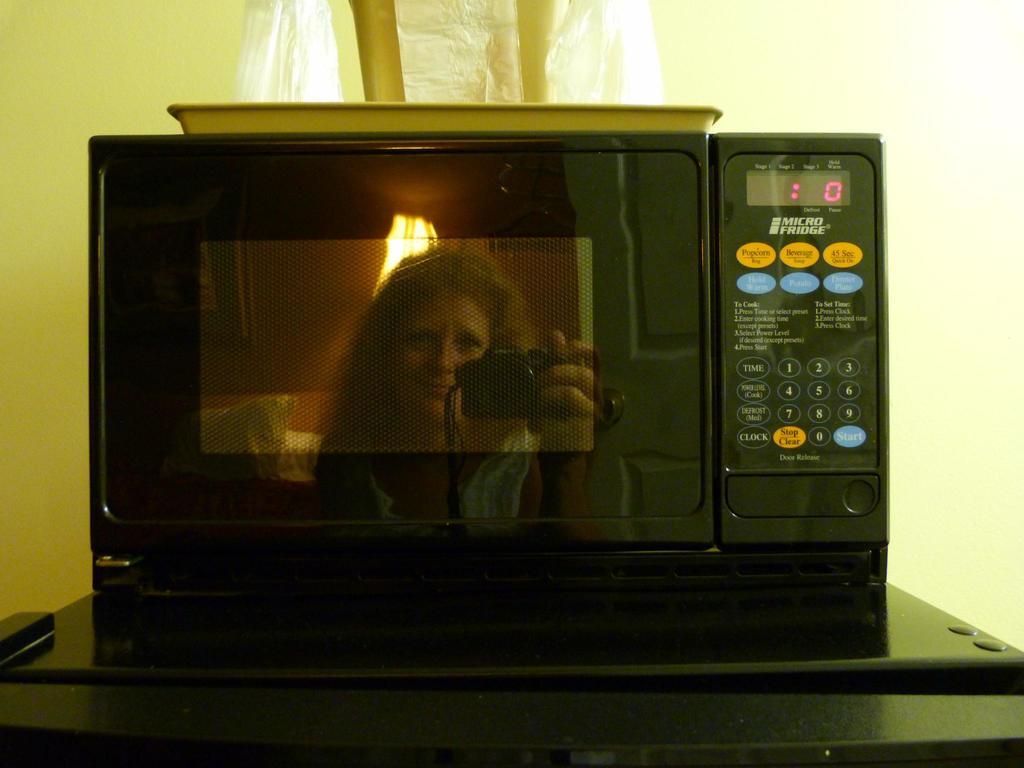How many seconds remain on the microwave timer?
Your answer should be very brief. 0. What brand of microwave is this?
Your response must be concise. Micro fridge. 